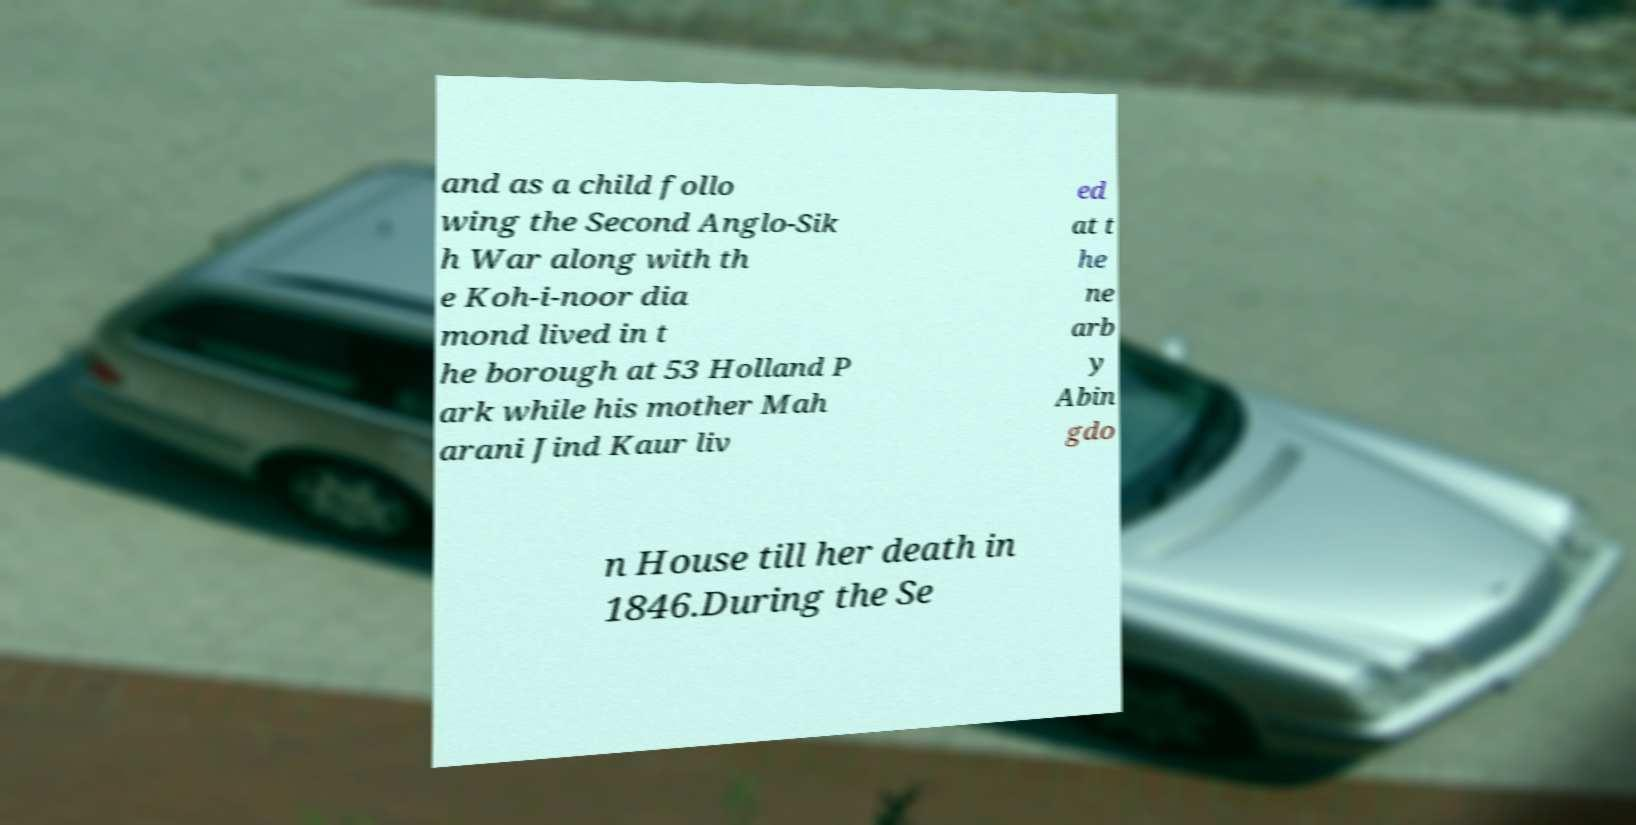For documentation purposes, I need the text within this image transcribed. Could you provide that? and as a child follo wing the Second Anglo-Sik h War along with th e Koh-i-noor dia mond lived in t he borough at 53 Holland P ark while his mother Mah arani Jind Kaur liv ed at t he ne arb y Abin gdo n House till her death in 1846.During the Se 